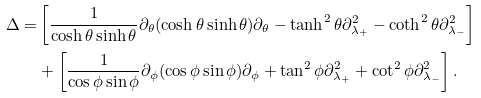Convert formula to latex. <formula><loc_0><loc_0><loc_500><loc_500>\Delta = & \left [ \frac { 1 } { \cosh \theta \sinh \theta } \partial _ { \theta } ( \cosh \theta \sinh \theta ) \partial _ { \theta } - \tanh ^ { 2 } \theta \partial _ { \lambda _ { + } } ^ { 2 } - \coth ^ { 2 } \theta \partial _ { \lambda _ { - } } ^ { 2 } \right ] \\ & + \left [ \frac { 1 } { \cos { \phi } \sin { \phi } } \partial _ { \phi } ( \cos { \phi } \sin { \phi } ) \partial _ { \phi } + \tan ^ { 2 } { \phi } \partial _ { \lambda _ { + } } ^ { 2 } + \cot ^ { 2 } { \phi } \partial _ { \lambda _ { - } } ^ { 2 } \right ] .</formula> 